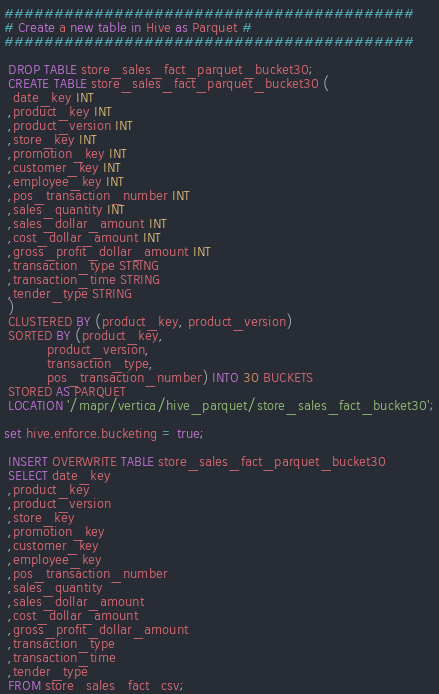<code> <loc_0><loc_0><loc_500><loc_500><_SQL_>#########################################
# Create a new table in Hive as Parquet #
#########################################

 DROP TABLE store_sales_fact_parquet_bucket30;
 CREATE TABLE store_sales_fact_parquet_bucket30 (
  date_key INT
 ,product_key INT
 ,product_version INT
 ,store_key INT
 ,promotion_key INT
 ,customer_key INT
 ,employee_key INT
 ,pos_transaction_number INT
 ,sales_quantity INT
 ,sales_dollar_amount INT
 ,cost_dollar_amount INT
 ,gross_profit_dollar_amount INT
 ,transaction_type STRING
 ,transaction_time STRING
 ,tender_type STRING
 )
 CLUSTERED BY (product_key, product_version)
 SORTED BY (product_key,
          product_version,
          transaction_type,
          pos_transaction_number) INTO 30 BUCKETS
 STORED AS PARQUET 
 LOCATION '/mapr/vertica/hive_parquet/store_sales_fact_bucket30';
 
set hive.enforce.bucketing = true;

 INSERT OVERWRITE TABLE store_sales_fact_parquet_bucket30
 SELECT date_key
 ,product_key
 ,product_version
 ,store_key
 ,promotion_key
 ,customer_key
 ,employee_key
 ,pos_transaction_number
 ,sales_quantity
 ,sales_dollar_amount
 ,cost_dollar_amount
 ,gross_profit_dollar_amount
 ,transaction_type
 ,transaction_time
 ,tender_type
 FROM store_sales_fact_csv;

</code> 